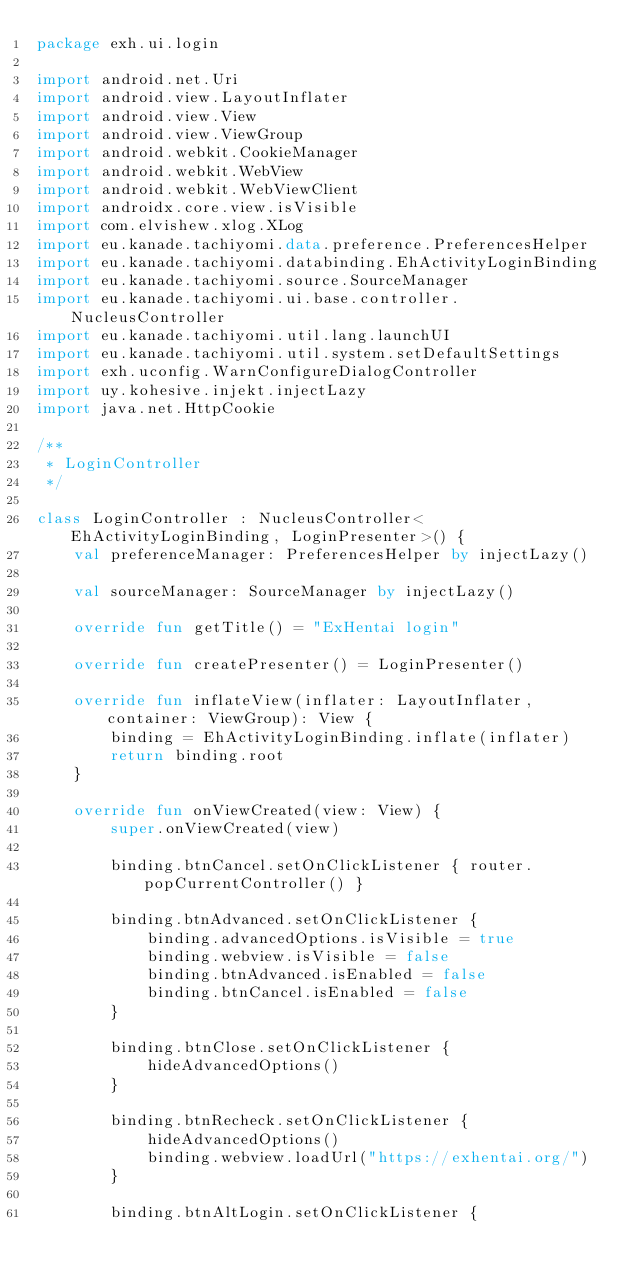<code> <loc_0><loc_0><loc_500><loc_500><_Kotlin_>package exh.ui.login

import android.net.Uri
import android.view.LayoutInflater
import android.view.View
import android.view.ViewGroup
import android.webkit.CookieManager
import android.webkit.WebView
import android.webkit.WebViewClient
import androidx.core.view.isVisible
import com.elvishew.xlog.XLog
import eu.kanade.tachiyomi.data.preference.PreferencesHelper
import eu.kanade.tachiyomi.databinding.EhActivityLoginBinding
import eu.kanade.tachiyomi.source.SourceManager
import eu.kanade.tachiyomi.ui.base.controller.NucleusController
import eu.kanade.tachiyomi.util.lang.launchUI
import eu.kanade.tachiyomi.util.system.setDefaultSettings
import exh.uconfig.WarnConfigureDialogController
import uy.kohesive.injekt.injectLazy
import java.net.HttpCookie

/**
 * LoginController
 */

class LoginController : NucleusController<EhActivityLoginBinding, LoginPresenter>() {
    val preferenceManager: PreferencesHelper by injectLazy()

    val sourceManager: SourceManager by injectLazy()

    override fun getTitle() = "ExHentai login"

    override fun createPresenter() = LoginPresenter()

    override fun inflateView(inflater: LayoutInflater, container: ViewGroup): View {
        binding = EhActivityLoginBinding.inflate(inflater)
        return binding.root
    }

    override fun onViewCreated(view: View) {
        super.onViewCreated(view)

        binding.btnCancel.setOnClickListener { router.popCurrentController() }

        binding.btnAdvanced.setOnClickListener {
            binding.advancedOptions.isVisible = true
            binding.webview.isVisible = false
            binding.btnAdvanced.isEnabled = false
            binding.btnCancel.isEnabled = false
        }

        binding.btnClose.setOnClickListener {
            hideAdvancedOptions()
        }

        binding.btnRecheck.setOnClickListener {
            hideAdvancedOptions()
            binding.webview.loadUrl("https://exhentai.org/")
        }

        binding.btnAltLogin.setOnClickListener {</code> 